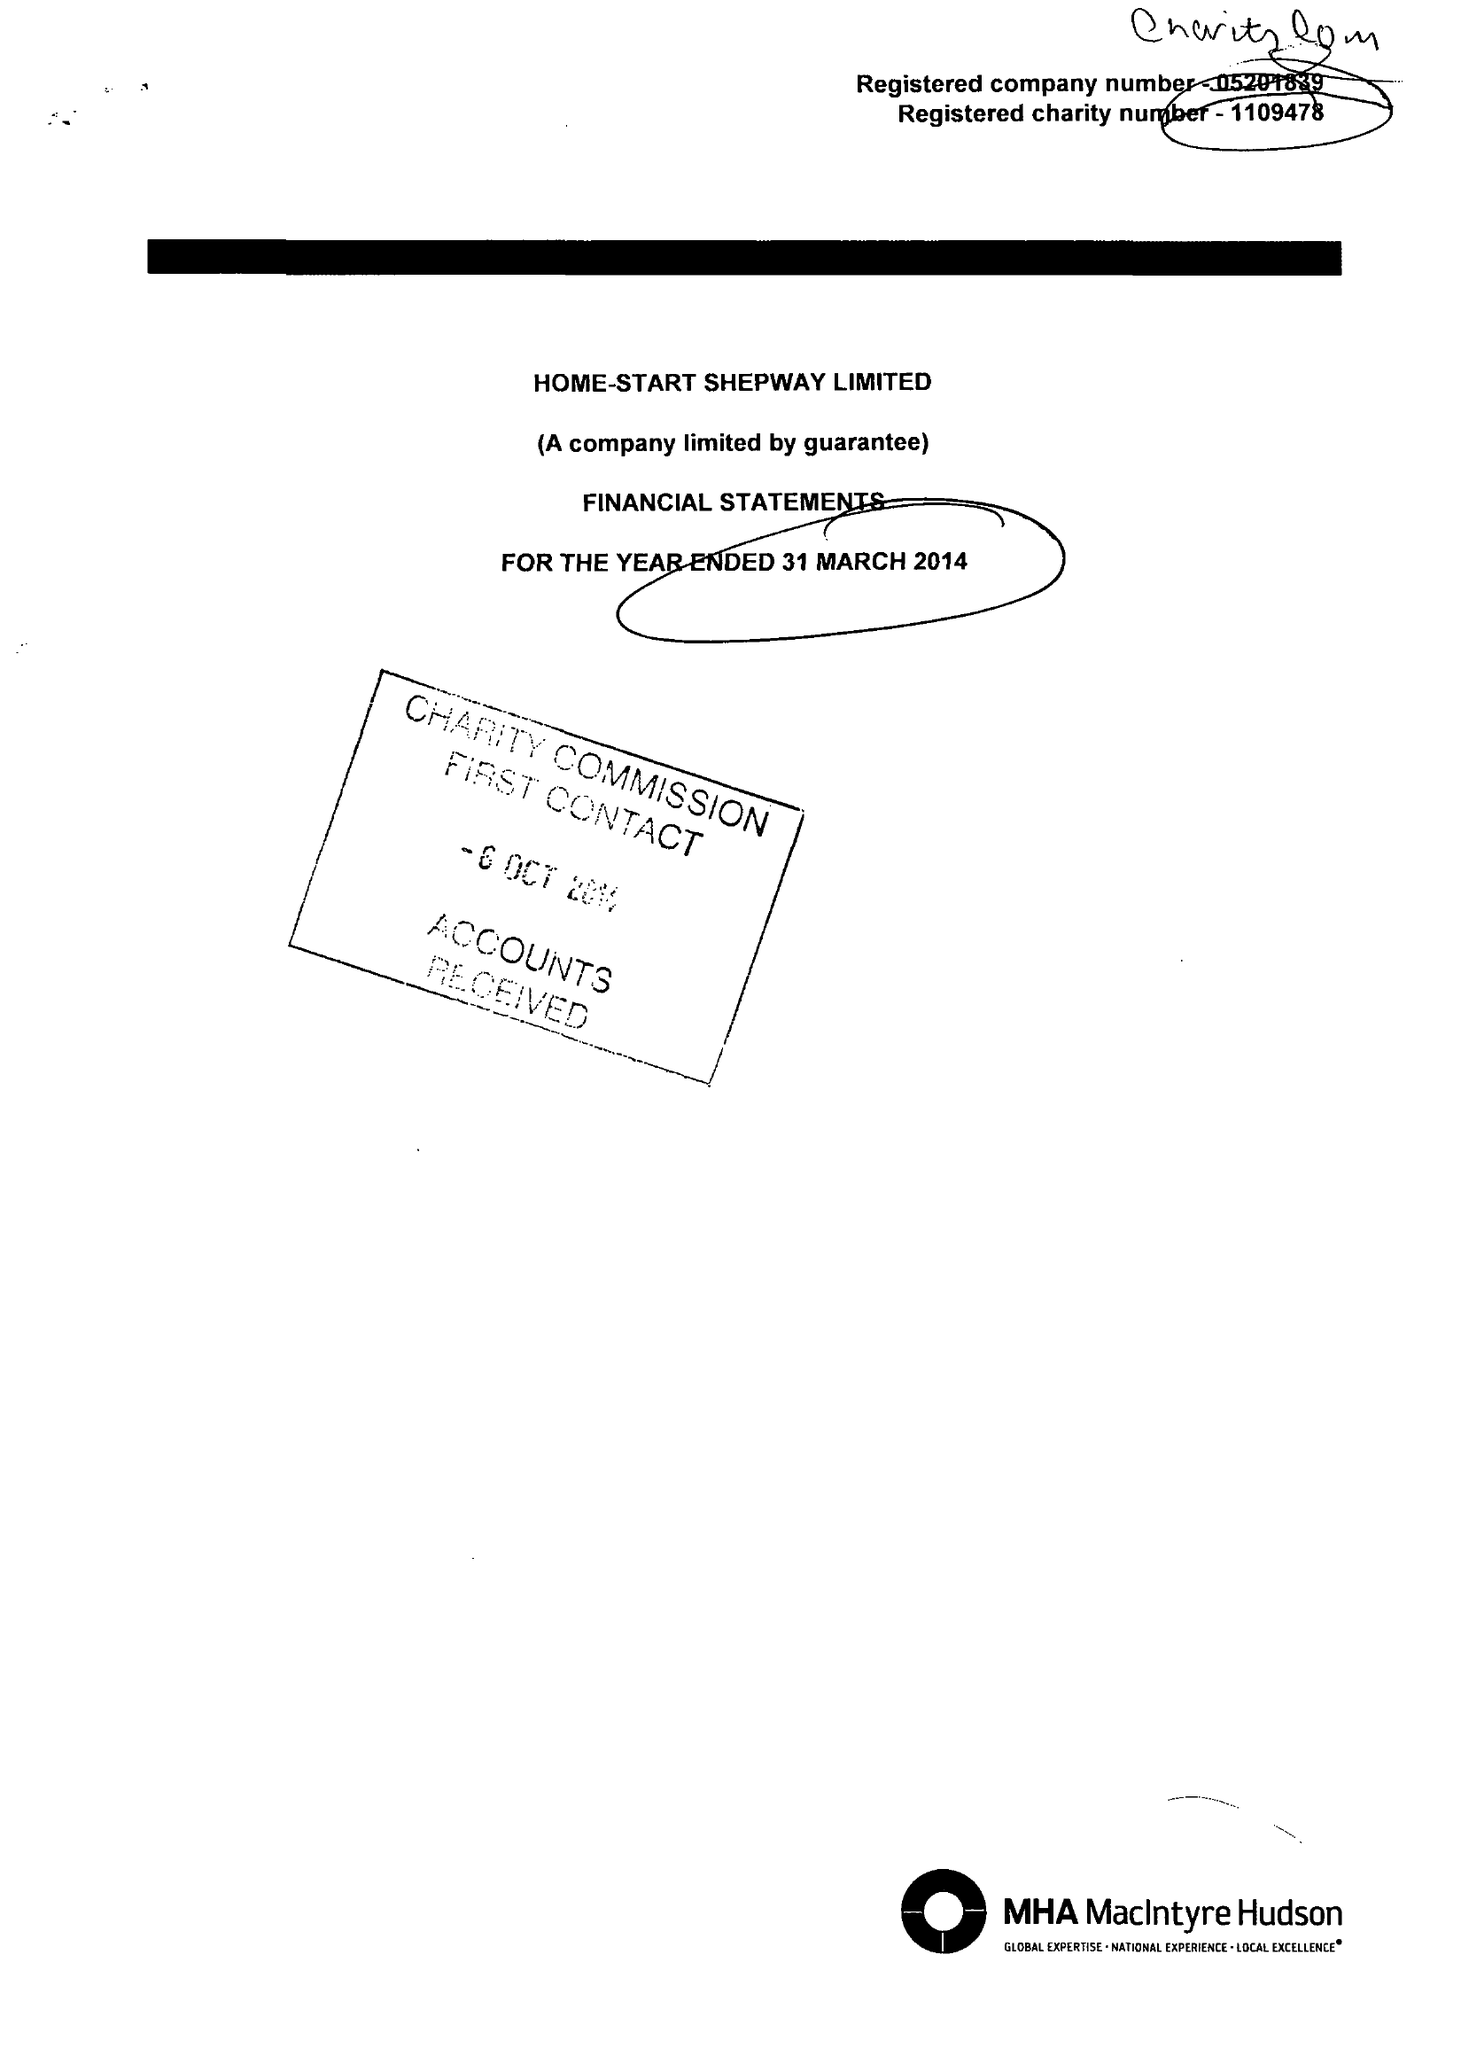What is the value for the income_annually_in_british_pounds?
Answer the question using a single word or phrase. 323014.00 